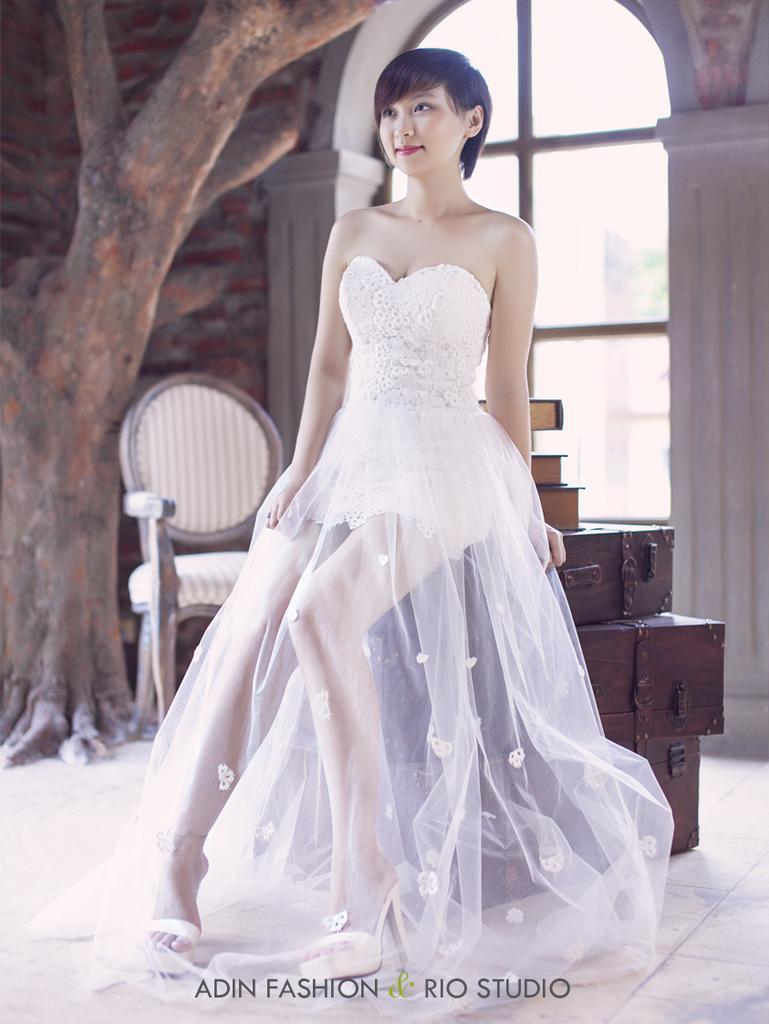Can you describe this image briefly? In front of the image there is a woman and at the bottom of the image there is some text, behind the woman there is a chair and some books on the luggage boxes, behind the chair there is a tree, behind the tree there is a glass window with pillars on the wall. 